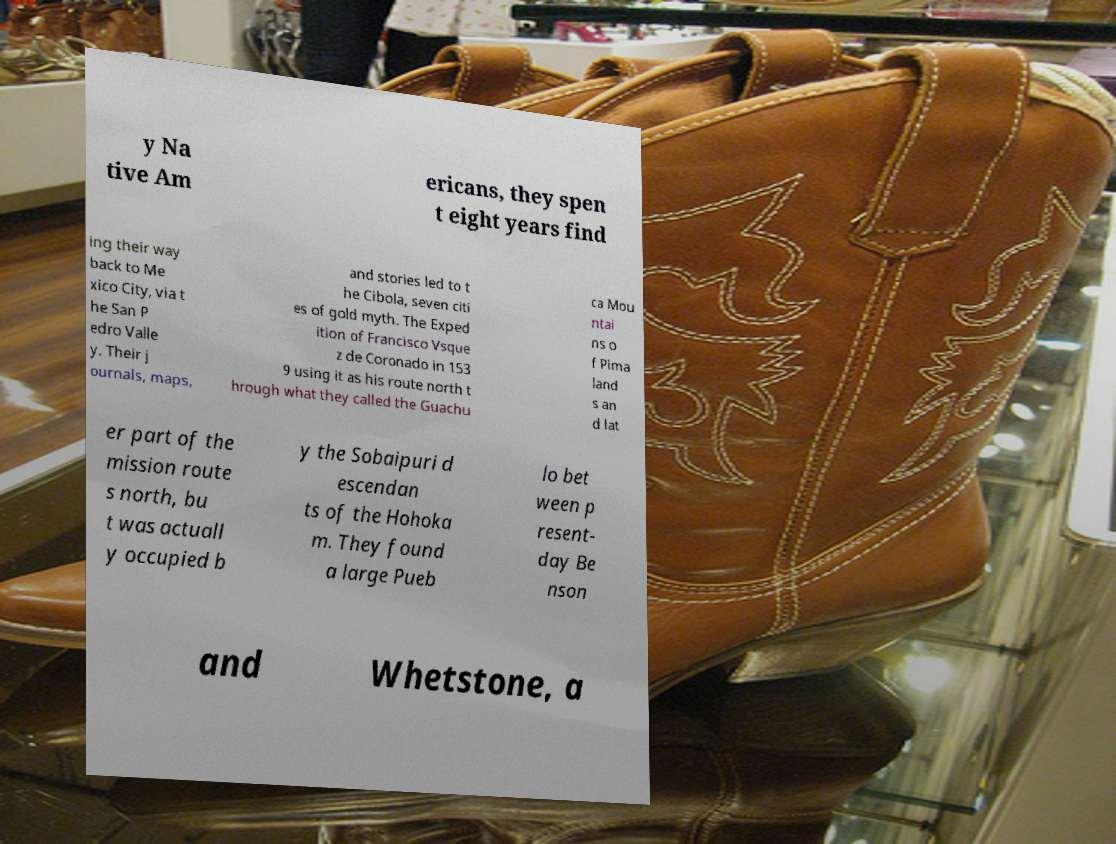Can you accurately transcribe the text from the provided image for me? y Na tive Am ericans, they spen t eight years find ing their way back to Me xico City, via t he San P edro Valle y. Their j ournals, maps, and stories led to t he Cibola, seven citi es of gold myth. The Exped ition of Francisco Vsque z de Coronado in 153 9 using it as his route north t hrough what they called the Guachu ca Mou ntai ns o f Pima land s an d lat er part of the mission route s north, bu t was actuall y occupied b y the Sobaipuri d escendan ts of the Hohoka m. They found a large Pueb lo bet ween p resent- day Be nson and Whetstone, a 